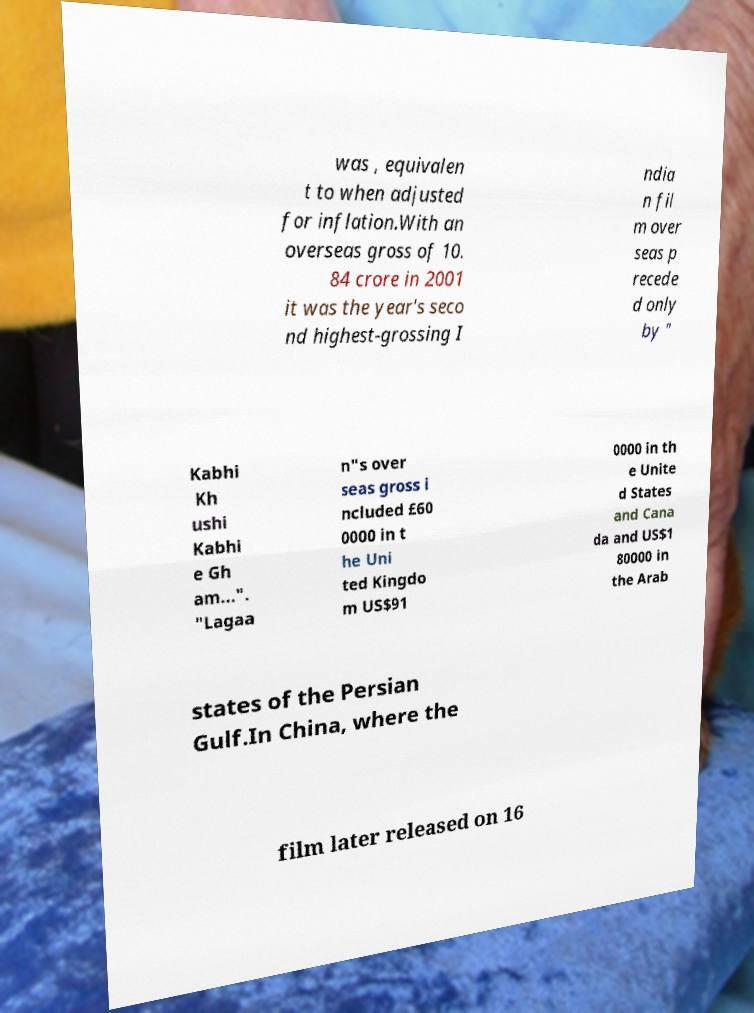Could you extract and type out the text from this image? was , equivalen t to when adjusted for inflation.With an overseas gross of 10. 84 crore in 2001 it was the year's seco nd highest-grossing I ndia n fil m over seas p recede d only by " Kabhi Kh ushi Kabhi e Gh am...". "Lagaa n"s over seas gross i ncluded £60 0000 in t he Uni ted Kingdo m US$91 0000 in th e Unite d States and Cana da and US$1 80000 in the Arab states of the Persian Gulf.In China, where the film later released on 16 